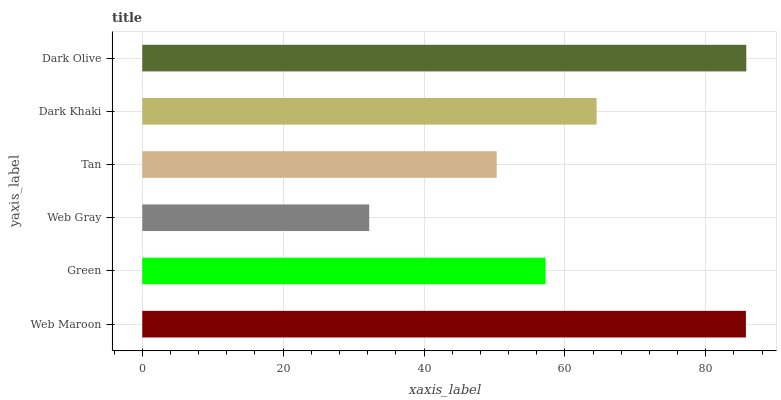Is Web Gray the minimum?
Answer yes or no. Yes. Is Dark Olive the maximum?
Answer yes or no. Yes. Is Green the minimum?
Answer yes or no. No. Is Green the maximum?
Answer yes or no. No. Is Web Maroon greater than Green?
Answer yes or no. Yes. Is Green less than Web Maroon?
Answer yes or no. Yes. Is Green greater than Web Maroon?
Answer yes or no. No. Is Web Maroon less than Green?
Answer yes or no. No. Is Dark Khaki the high median?
Answer yes or no. Yes. Is Green the low median?
Answer yes or no. Yes. Is Green the high median?
Answer yes or no. No. Is Tan the low median?
Answer yes or no. No. 